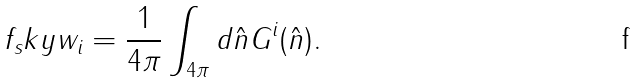<formula> <loc_0><loc_0><loc_500><loc_500>f _ { s } k y w _ { i } = \frac { 1 } { 4 \pi } \int _ { 4 \pi } d { \hat { n } } G ^ { i } ( { \hat { n } } ) .</formula> 